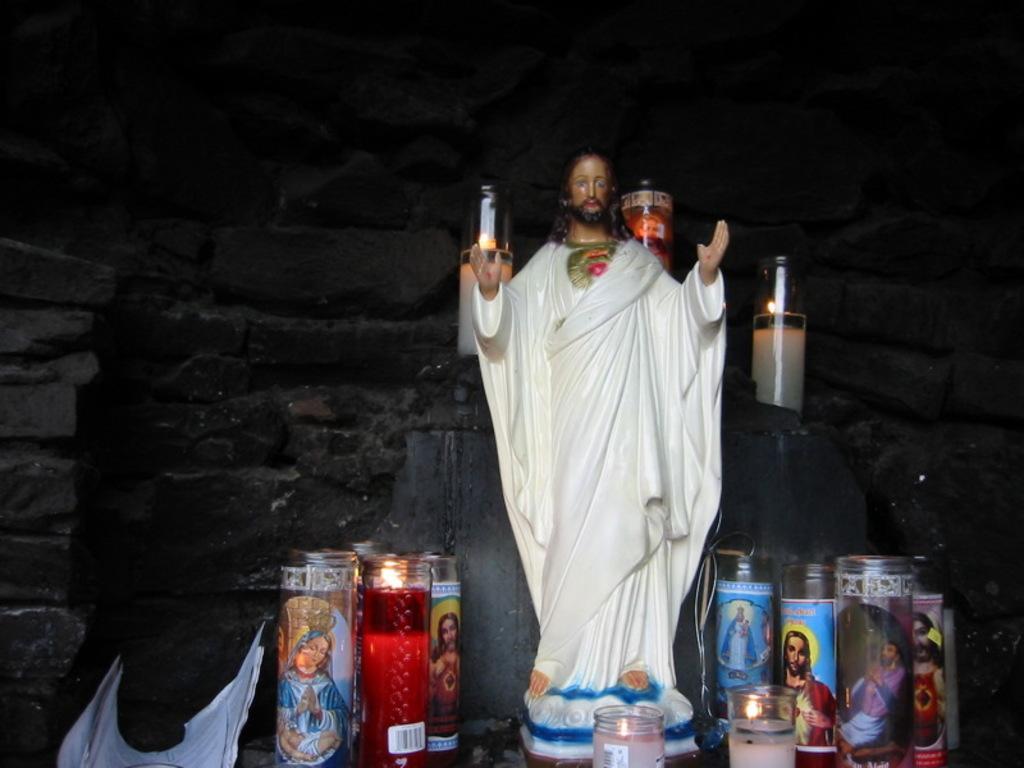In one or two sentences, can you explain what this image depicts? In this picture I can see a statue of Jesus and candles. In the background I can see a wall. 